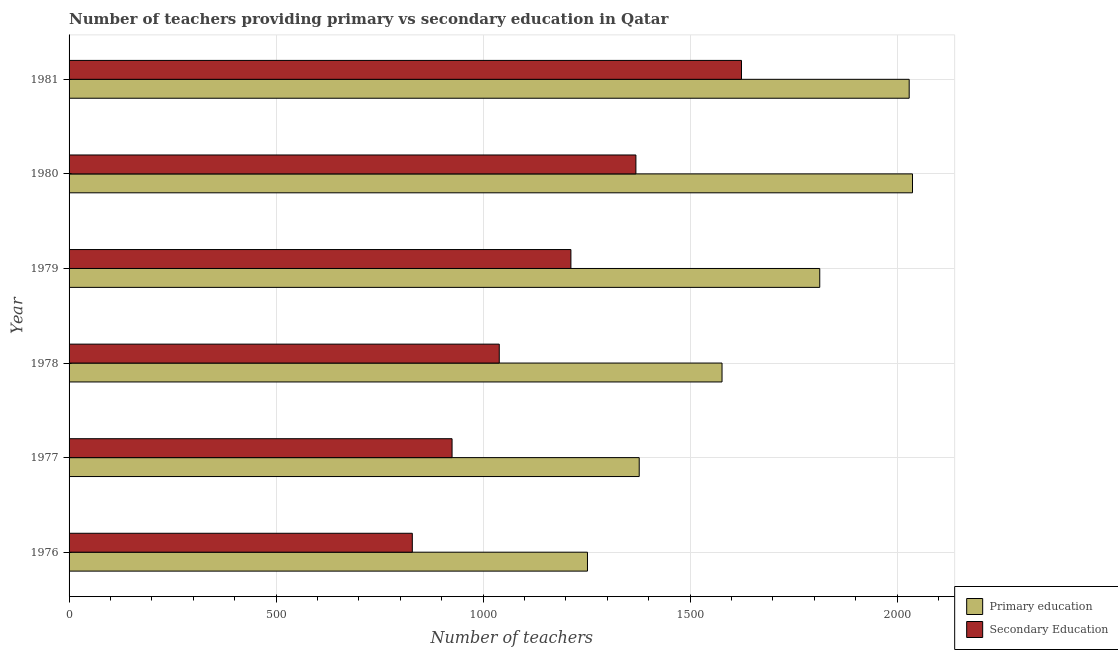How many different coloured bars are there?
Provide a short and direct response. 2. Are the number of bars on each tick of the Y-axis equal?
Offer a terse response. Yes. How many bars are there on the 5th tick from the top?
Your answer should be compact. 2. How many bars are there on the 1st tick from the bottom?
Offer a very short reply. 2. What is the number of secondary teachers in 1978?
Make the answer very short. 1039. Across all years, what is the maximum number of secondary teachers?
Give a very brief answer. 1624. Across all years, what is the minimum number of primary teachers?
Provide a succinct answer. 1252. In which year was the number of secondary teachers maximum?
Provide a short and direct response. 1981. In which year was the number of secondary teachers minimum?
Offer a very short reply. 1976. What is the total number of primary teachers in the graph?
Make the answer very short. 1.01e+04. What is the difference between the number of primary teachers in 1977 and that in 1978?
Your answer should be compact. -200. What is the difference between the number of secondary teachers in 1981 and the number of primary teachers in 1978?
Offer a very short reply. 47. What is the average number of primary teachers per year?
Provide a short and direct response. 1680.83. In the year 1980, what is the difference between the number of secondary teachers and number of primary teachers?
Your answer should be very brief. -668. In how many years, is the number of primary teachers greater than 1600 ?
Keep it short and to the point. 3. What is the ratio of the number of primary teachers in 1977 to that in 1980?
Keep it short and to the point. 0.68. Is the number of primary teachers in 1978 less than that in 1981?
Your answer should be compact. Yes. What is the difference between the highest and the second highest number of secondary teachers?
Ensure brevity in your answer.  255. What is the difference between the highest and the lowest number of secondary teachers?
Offer a terse response. 795. Is the sum of the number of secondary teachers in 1977 and 1981 greater than the maximum number of primary teachers across all years?
Your response must be concise. Yes. What does the 1st bar from the top in 1981 represents?
Give a very brief answer. Secondary Education. What does the 2nd bar from the bottom in 1979 represents?
Keep it short and to the point. Secondary Education. How many bars are there?
Provide a succinct answer. 12. What is the difference between two consecutive major ticks on the X-axis?
Ensure brevity in your answer.  500. How many legend labels are there?
Provide a short and direct response. 2. What is the title of the graph?
Ensure brevity in your answer.  Number of teachers providing primary vs secondary education in Qatar. What is the label or title of the X-axis?
Make the answer very short. Number of teachers. What is the Number of teachers in Primary education in 1976?
Make the answer very short. 1252. What is the Number of teachers of Secondary Education in 1976?
Provide a succinct answer. 829. What is the Number of teachers in Primary education in 1977?
Offer a terse response. 1377. What is the Number of teachers in Secondary Education in 1977?
Keep it short and to the point. 925. What is the Number of teachers in Primary education in 1978?
Your response must be concise. 1577. What is the Number of teachers of Secondary Education in 1978?
Give a very brief answer. 1039. What is the Number of teachers in Primary education in 1979?
Keep it short and to the point. 1813. What is the Number of teachers in Secondary Education in 1979?
Keep it short and to the point. 1212. What is the Number of teachers of Primary education in 1980?
Offer a very short reply. 2037. What is the Number of teachers in Secondary Education in 1980?
Ensure brevity in your answer.  1369. What is the Number of teachers in Primary education in 1981?
Ensure brevity in your answer.  2029. What is the Number of teachers in Secondary Education in 1981?
Offer a terse response. 1624. Across all years, what is the maximum Number of teachers of Primary education?
Your response must be concise. 2037. Across all years, what is the maximum Number of teachers in Secondary Education?
Provide a short and direct response. 1624. Across all years, what is the minimum Number of teachers in Primary education?
Offer a very short reply. 1252. Across all years, what is the minimum Number of teachers of Secondary Education?
Your response must be concise. 829. What is the total Number of teachers of Primary education in the graph?
Your answer should be compact. 1.01e+04. What is the total Number of teachers of Secondary Education in the graph?
Make the answer very short. 6998. What is the difference between the Number of teachers in Primary education in 1976 and that in 1977?
Offer a terse response. -125. What is the difference between the Number of teachers in Secondary Education in 1976 and that in 1977?
Offer a terse response. -96. What is the difference between the Number of teachers in Primary education in 1976 and that in 1978?
Your answer should be very brief. -325. What is the difference between the Number of teachers of Secondary Education in 1976 and that in 1978?
Make the answer very short. -210. What is the difference between the Number of teachers of Primary education in 1976 and that in 1979?
Provide a succinct answer. -561. What is the difference between the Number of teachers in Secondary Education in 1976 and that in 1979?
Offer a very short reply. -383. What is the difference between the Number of teachers in Primary education in 1976 and that in 1980?
Make the answer very short. -785. What is the difference between the Number of teachers in Secondary Education in 1976 and that in 1980?
Keep it short and to the point. -540. What is the difference between the Number of teachers in Primary education in 1976 and that in 1981?
Provide a short and direct response. -777. What is the difference between the Number of teachers of Secondary Education in 1976 and that in 1981?
Ensure brevity in your answer.  -795. What is the difference between the Number of teachers of Primary education in 1977 and that in 1978?
Your answer should be compact. -200. What is the difference between the Number of teachers in Secondary Education in 1977 and that in 1978?
Keep it short and to the point. -114. What is the difference between the Number of teachers in Primary education in 1977 and that in 1979?
Offer a terse response. -436. What is the difference between the Number of teachers of Secondary Education in 1977 and that in 1979?
Make the answer very short. -287. What is the difference between the Number of teachers of Primary education in 1977 and that in 1980?
Your answer should be very brief. -660. What is the difference between the Number of teachers in Secondary Education in 1977 and that in 1980?
Give a very brief answer. -444. What is the difference between the Number of teachers in Primary education in 1977 and that in 1981?
Offer a terse response. -652. What is the difference between the Number of teachers in Secondary Education in 1977 and that in 1981?
Your response must be concise. -699. What is the difference between the Number of teachers in Primary education in 1978 and that in 1979?
Your answer should be very brief. -236. What is the difference between the Number of teachers in Secondary Education in 1978 and that in 1979?
Your answer should be compact. -173. What is the difference between the Number of teachers of Primary education in 1978 and that in 1980?
Your response must be concise. -460. What is the difference between the Number of teachers of Secondary Education in 1978 and that in 1980?
Give a very brief answer. -330. What is the difference between the Number of teachers of Primary education in 1978 and that in 1981?
Provide a short and direct response. -452. What is the difference between the Number of teachers of Secondary Education in 1978 and that in 1981?
Provide a succinct answer. -585. What is the difference between the Number of teachers of Primary education in 1979 and that in 1980?
Offer a very short reply. -224. What is the difference between the Number of teachers of Secondary Education in 1979 and that in 1980?
Give a very brief answer. -157. What is the difference between the Number of teachers of Primary education in 1979 and that in 1981?
Your response must be concise. -216. What is the difference between the Number of teachers in Secondary Education in 1979 and that in 1981?
Your answer should be very brief. -412. What is the difference between the Number of teachers in Secondary Education in 1980 and that in 1981?
Provide a succinct answer. -255. What is the difference between the Number of teachers of Primary education in 1976 and the Number of teachers of Secondary Education in 1977?
Offer a very short reply. 327. What is the difference between the Number of teachers in Primary education in 1976 and the Number of teachers in Secondary Education in 1978?
Give a very brief answer. 213. What is the difference between the Number of teachers in Primary education in 1976 and the Number of teachers in Secondary Education in 1979?
Your answer should be compact. 40. What is the difference between the Number of teachers in Primary education in 1976 and the Number of teachers in Secondary Education in 1980?
Provide a short and direct response. -117. What is the difference between the Number of teachers in Primary education in 1976 and the Number of teachers in Secondary Education in 1981?
Offer a terse response. -372. What is the difference between the Number of teachers in Primary education in 1977 and the Number of teachers in Secondary Education in 1978?
Make the answer very short. 338. What is the difference between the Number of teachers in Primary education in 1977 and the Number of teachers in Secondary Education in 1979?
Your answer should be compact. 165. What is the difference between the Number of teachers in Primary education in 1977 and the Number of teachers in Secondary Education in 1980?
Your answer should be compact. 8. What is the difference between the Number of teachers in Primary education in 1977 and the Number of teachers in Secondary Education in 1981?
Give a very brief answer. -247. What is the difference between the Number of teachers in Primary education in 1978 and the Number of teachers in Secondary Education in 1979?
Make the answer very short. 365. What is the difference between the Number of teachers of Primary education in 1978 and the Number of teachers of Secondary Education in 1980?
Provide a short and direct response. 208. What is the difference between the Number of teachers in Primary education in 1978 and the Number of teachers in Secondary Education in 1981?
Make the answer very short. -47. What is the difference between the Number of teachers of Primary education in 1979 and the Number of teachers of Secondary Education in 1980?
Ensure brevity in your answer.  444. What is the difference between the Number of teachers in Primary education in 1979 and the Number of teachers in Secondary Education in 1981?
Offer a terse response. 189. What is the difference between the Number of teachers of Primary education in 1980 and the Number of teachers of Secondary Education in 1981?
Keep it short and to the point. 413. What is the average Number of teachers of Primary education per year?
Ensure brevity in your answer.  1680.83. What is the average Number of teachers in Secondary Education per year?
Ensure brevity in your answer.  1166.33. In the year 1976, what is the difference between the Number of teachers of Primary education and Number of teachers of Secondary Education?
Keep it short and to the point. 423. In the year 1977, what is the difference between the Number of teachers of Primary education and Number of teachers of Secondary Education?
Give a very brief answer. 452. In the year 1978, what is the difference between the Number of teachers of Primary education and Number of teachers of Secondary Education?
Your answer should be compact. 538. In the year 1979, what is the difference between the Number of teachers in Primary education and Number of teachers in Secondary Education?
Offer a very short reply. 601. In the year 1980, what is the difference between the Number of teachers of Primary education and Number of teachers of Secondary Education?
Give a very brief answer. 668. In the year 1981, what is the difference between the Number of teachers in Primary education and Number of teachers in Secondary Education?
Your answer should be very brief. 405. What is the ratio of the Number of teachers of Primary education in 1976 to that in 1977?
Give a very brief answer. 0.91. What is the ratio of the Number of teachers of Secondary Education in 1976 to that in 1977?
Your answer should be compact. 0.9. What is the ratio of the Number of teachers in Primary education in 1976 to that in 1978?
Keep it short and to the point. 0.79. What is the ratio of the Number of teachers of Secondary Education in 1976 to that in 1978?
Provide a succinct answer. 0.8. What is the ratio of the Number of teachers in Primary education in 1976 to that in 1979?
Provide a succinct answer. 0.69. What is the ratio of the Number of teachers of Secondary Education in 1976 to that in 1979?
Your response must be concise. 0.68. What is the ratio of the Number of teachers of Primary education in 1976 to that in 1980?
Offer a very short reply. 0.61. What is the ratio of the Number of teachers of Secondary Education in 1976 to that in 1980?
Offer a terse response. 0.61. What is the ratio of the Number of teachers of Primary education in 1976 to that in 1981?
Offer a terse response. 0.62. What is the ratio of the Number of teachers in Secondary Education in 1976 to that in 1981?
Keep it short and to the point. 0.51. What is the ratio of the Number of teachers of Primary education in 1977 to that in 1978?
Make the answer very short. 0.87. What is the ratio of the Number of teachers in Secondary Education in 1977 to that in 1978?
Offer a terse response. 0.89. What is the ratio of the Number of teachers in Primary education in 1977 to that in 1979?
Provide a succinct answer. 0.76. What is the ratio of the Number of teachers of Secondary Education in 1977 to that in 1979?
Your answer should be compact. 0.76. What is the ratio of the Number of teachers of Primary education in 1977 to that in 1980?
Your answer should be very brief. 0.68. What is the ratio of the Number of teachers of Secondary Education in 1977 to that in 1980?
Your answer should be compact. 0.68. What is the ratio of the Number of teachers in Primary education in 1977 to that in 1981?
Keep it short and to the point. 0.68. What is the ratio of the Number of teachers of Secondary Education in 1977 to that in 1981?
Keep it short and to the point. 0.57. What is the ratio of the Number of teachers in Primary education in 1978 to that in 1979?
Keep it short and to the point. 0.87. What is the ratio of the Number of teachers of Secondary Education in 1978 to that in 1979?
Keep it short and to the point. 0.86. What is the ratio of the Number of teachers in Primary education in 1978 to that in 1980?
Your answer should be very brief. 0.77. What is the ratio of the Number of teachers of Secondary Education in 1978 to that in 1980?
Give a very brief answer. 0.76. What is the ratio of the Number of teachers in Primary education in 1978 to that in 1981?
Make the answer very short. 0.78. What is the ratio of the Number of teachers in Secondary Education in 1978 to that in 1981?
Your answer should be compact. 0.64. What is the ratio of the Number of teachers of Primary education in 1979 to that in 1980?
Your answer should be compact. 0.89. What is the ratio of the Number of teachers in Secondary Education in 1979 to that in 1980?
Your response must be concise. 0.89. What is the ratio of the Number of teachers in Primary education in 1979 to that in 1981?
Your answer should be compact. 0.89. What is the ratio of the Number of teachers of Secondary Education in 1979 to that in 1981?
Your response must be concise. 0.75. What is the ratio of the Number of teachers in Secondary Education in 1980 to that in 1981?
Your response must be concise. 0.84. What is the difference between the highest and the second highest Number of teachers in Primary education?
Give a very brief answer. 8. What is the difference between the highest and the second highest Number of teachers of Secondary Education?
Your response must be concise. 255. What is the difference between the highest and the lowest Number of teachers of Primary education?
Provide a short and direct response. 785. What is the difference between the highest and the lowest Number of teachers of Secondary Education?
Provide a succinct answer. 795. 